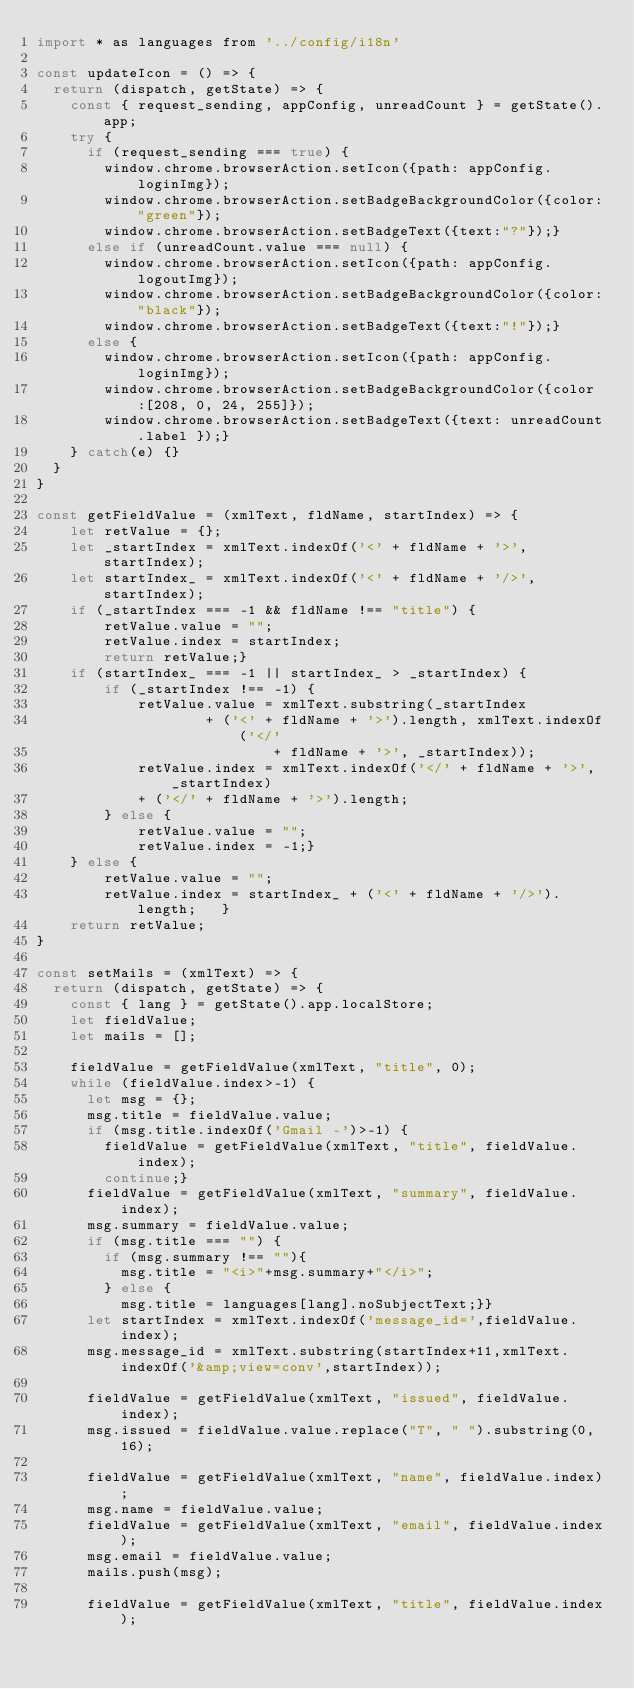<code> <loc_0><loc_0><loc_500><loc_500><_JavaScript_>import * as languages from '../config/i18n'

const updateIcon = () => {
  return (dispatch, getState) => {
    const { request_sending, appConfig, unreadCount } = getState().app;
    try {
      if (request_sending === true) {
        window.chrome.browserAction.setIcon({path: appConfig.loginImg});
        window.chrome.browserAction.setBadgeBackgroundColor({color:"green"});
        window.chrome.browserAction.setBadgeText({text:"?"});}
      else if (unreadCount.value === null) {
        window.chrome.browserAction.setIcon({path: appConfig.logoutImg});
        window.chrome.browserAction.setBadgeBackgroundColor({color:"black"});
        window.chrome.browserAction.setBadgeText({text:"!"});} 
      else {
        window.chrome.browserAction.setIcon({path: appConfig.loginImg});
        window.chrome.browserAction.setBadgeBackgroundColor({color:[208, 0, 24, 255]});
        window.chrome.browserAction.setBadgeText({text: unreadCount.label });}
    } catch(e) {}
  }
}

const getFieldValue = (xmlText, fldName, startIndex) => {
	let retValue = {};
	let _startIndex = xmlText.indexOf('<' + fldName + '>', startIndex);
	let startIndex_ = xmlText.indexOf('<' + fldName + '/>', startIndex);
	if (_startIndex === -1 && fldName !== "title") {
		retValue.value = "";
		retValue.index = startIndex;
		return retValue;}
	if (startIndex_ === -1 || startIndex_ > _startIndex) {
		if (_startIndex !== -1) {
			retValue.value = xmlText.substring(_startIndex
					+ ('<' + fldName + '>').length, xmlText.indexOf('</'
							+ fldName + '>', _startIndex));
			retValue.index = xmlText.indexOf('</' + fldName + '>', _startIndex)
			+ ('</' + fldName + '>').length;
		} else {
			retValue.value = "";
			retValue.index = -1;}
	} else {
		retValue.value = "";
		retValue.index = startIndex_ + ('<' + fldName + '/>').length;	}
	return retValue;
}

const setMails = (xmlText) => {
  return (dispatch, getState) => {
    const { lang } = getState().app.localStore;
    let fieldValue;
    let mails = [];
    
    fieldValue = getFieldValue(xmlText, "title", 0);
    while (fieldValue.index>-1) {
      let msg = {};
      msg.title = fieldValue.value;
      if (msg.title.indexOf('Gmail -')>-1) {
        fieldValue = getFieldValue(xmlText, "title", fieldValue.index);
        continue;}
      fieldValue = getFieldValue(xmlText, "summary", fieldValue.index);
      msg.summary = fieldValue.value;
      if (msg.title === "") {
        if (msg.summary !== ""){
          msg.title = "<i>"+msg.summary+"</i>";
        } else {
          msg.title = languages[lang].noSubjectText;}}
      let startIndex = xmlText.indexOf('message_id=',fieldValue.index);
      msg.message_id = xmlText.substring(startIndex+11,xmlText.indexOf('&amp;view=conv',startIndex));
      
      fieldValue = getFieldValue(xmlText, "issued", fieldValue.index);
      msg.issued = fieldValue.value.replace("T", " ").substring(0, 16); 
      
      fieldValue = getFieldValue(xmlText, "name", fieldValue.index);
      msg.name = fieldValue.value;
      fieldValue = getFieldValue(xmlText, "email", fieldValue.index);
      msg.email = fieldValue.value;
      mails.push(msg);

      fieldValue = getFieldValue(xmlText, "title", fieldValue.index);</code> 